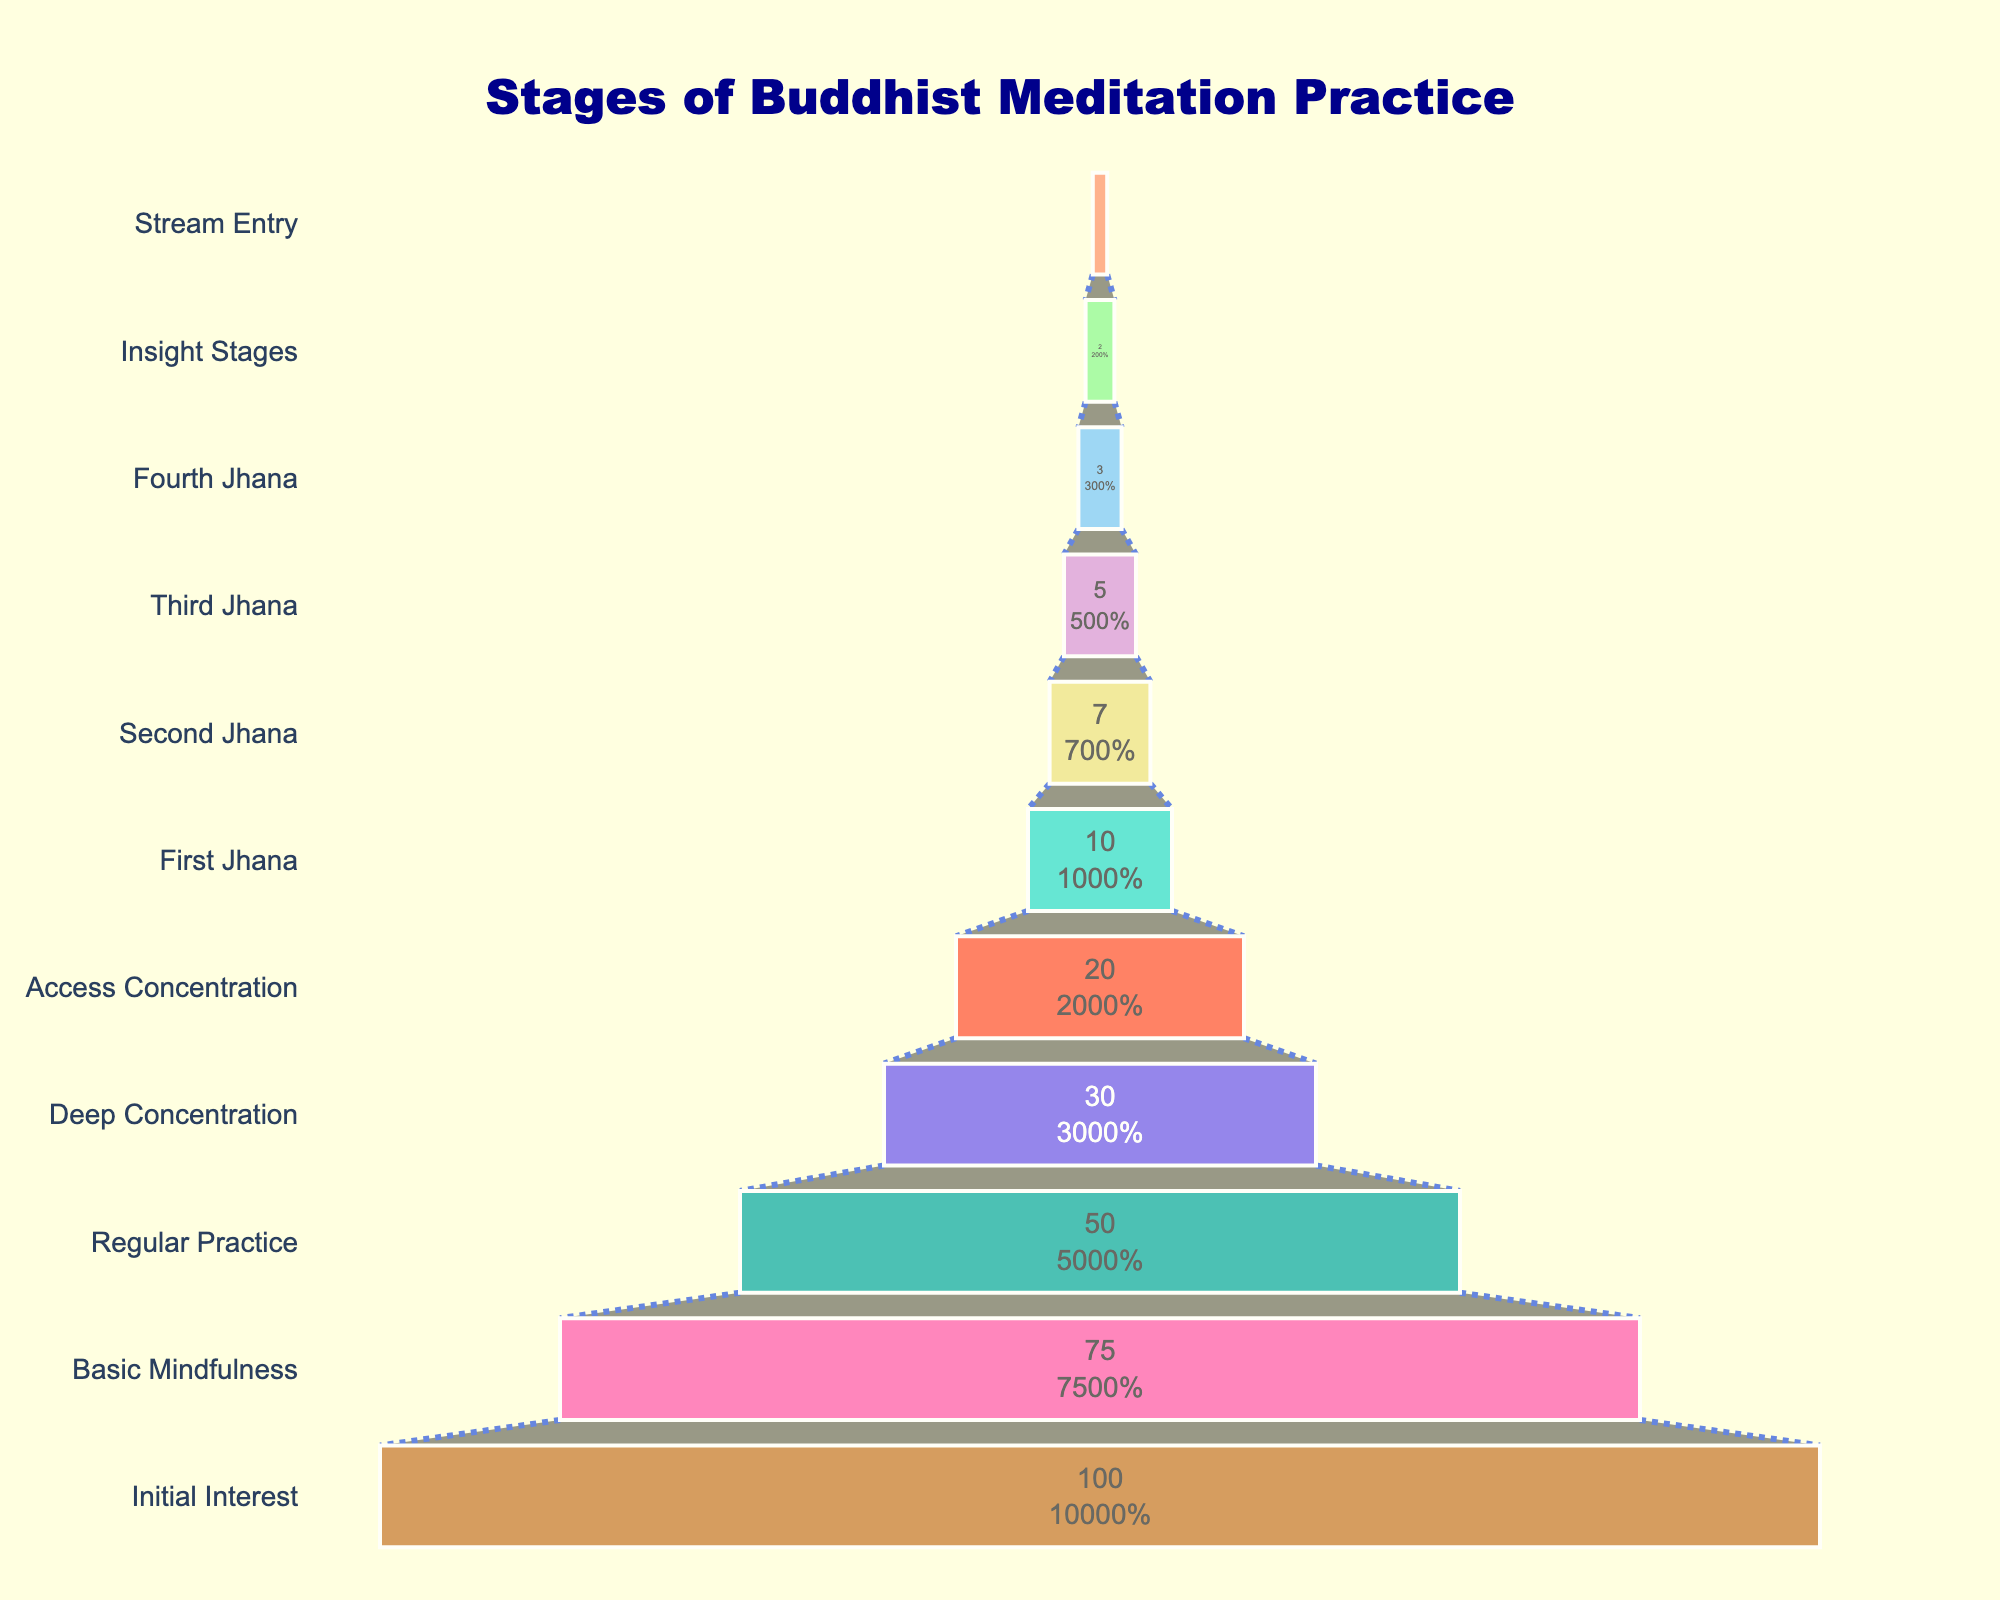What is the title of the funnel chart? The title normally appears at the top of the chart. In this case, it reads "Stages of Buddhist Meditation Practice".
Answer: Stages of Buddhist Meditation Practice What percentage of practitioners reach the "Basic Mindfulness" stage? By reading the chart, you can see that the percentage next to the "Basic Mindfulness" stage is 75%.
Answer: 75% How many stages are depicted in the funnel chart? Counting the number of different stages listed on the y-axis gives the total number of stages.
Answer: 11 Which stage has the lowest percentage of practitioners achieving it? The smallest percentage value is at the bottom of the chart, indicating the "Stream Entry" stage with 1%.
Answer: Stream Entry What is the total percentage of practitioners from the "Regular Practice" stage to the "Third Jhana"? From "Regular Practice" (50%) to "Third Jhana" (5%), sum their percentages: 50 + 30 + 20 + 10 + 7 + 5 = 122.
Answer: 122% How do the percentages drop from "Deep Concentration" to "Access Concentration"? By subtracting the percentage of "Access Concentration" (20%) from that of "Deep Concentration" (30%), the drop is 30 - 20 = 10.
Answer: 10% Compare the percentages of practitioners achieving the "First Jhana" and "Fourth Jhana". Which stage has more practitioners? By comparing the values, "First Jhana" has 10% while "Fourth Jhana" has 3%.
Answer: First Jhana What is the difference in percentage between the "Second Jhana" and "Third Jhana"? By subtracting the percentage of "Third Jhana" (5%) from that of "Second Jhana" (7%), the difference is 7 - 5 = 2.
Answer: 2% What does the background color of the chart appear to be? The background color mentioned is 'lightyellow', which gives a light and warm appearance to the chart.
Answer: lightyellow What percentage of practitioners achieve beyond "Access Concentration"? Adding up the percentages from "First Jhana" to "Stream Entry" gives: 10 + 7 + 5 + 3 + 2 + 1 = 28.
Answer: 28% 